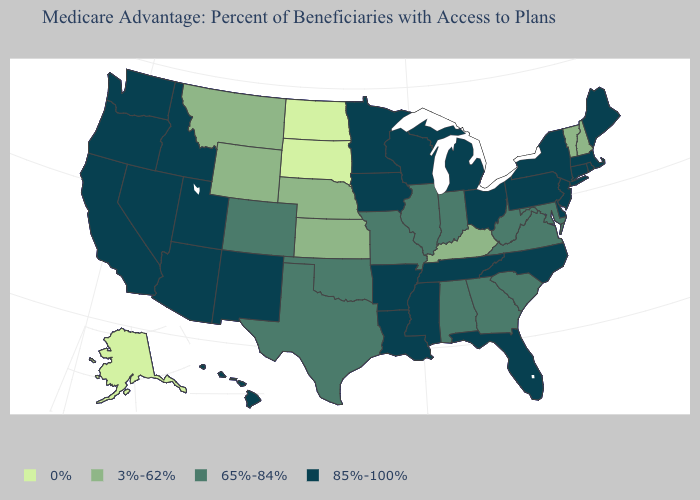What is the highest value in states that border North Carolina?
Quick response, please. 85%-100%. Does Florida have the same value as Illinois?
Short answer required. No. What is the value of Illinois?
Be succinct. 65%-84%. What is the value of West Virginia?
Concise answer only. 65%-84%. Name the states that have a value in the range 85%-100%?
Keep it brief. Arkansas, Arizona, California, Connecticut, Delaware, Florida, Hawaii, Iowa, Idaho, Louisiana, Massachusetts, Maine, Michigan, Minnesota, Mississippi, North Carolina, New Jersey, New Mexico, Nevada, New York, Ohio, Oregon, Pennsylvania, Rhode Island, Tennessee, Utah, Washington, Wisconsin. What is the value of Wisconsin?
Answer briefly. 85%-100%. Name the states that have a value in the range 65%-84%?
Give a very brief answer. Alabama, Colorado, Georgia, Illinois, Indiana, Maryland, Missouri, Oklahoma, South Carolina, Texas, Virginia, West Virginia. What is the value of New Jersey?
Short answer required. 85%-100%. Which states have the lowest value in the USA?
Answer briefly. Alaska, North Dakota, South Dakota. Is the legend a continuous bar?
Write a very short answer. No. What is the value of Texas?
Be succinct. 65%-84%. Does Idaho have a higher value than Massachusetts?
Quick response, please. No. Name the states that have a value in the range 85%-100%?
Quick response, please. Arkansas, Arizona, California, Connecticut, Delaware, Florida, Hawaii, Iowa, Idaho, Louisiana, Massachusetts, Maine, Michigan, Minnesota, Mississippi, North Carolina, New Jersey, New Mexico, Nevada, New York, Ohio, Oregon, Pennsylvania, Rhode Island, Tennessee, Utah, Washington, Wisconsin. Which states hav the highest value in the West?
Short answer required. Arizona, California, Hawaii, Idaho, New Mexico, Nevada, Oregon, Utah, Washington. Is the legend a continuous bar?
Answer briefly. No. 